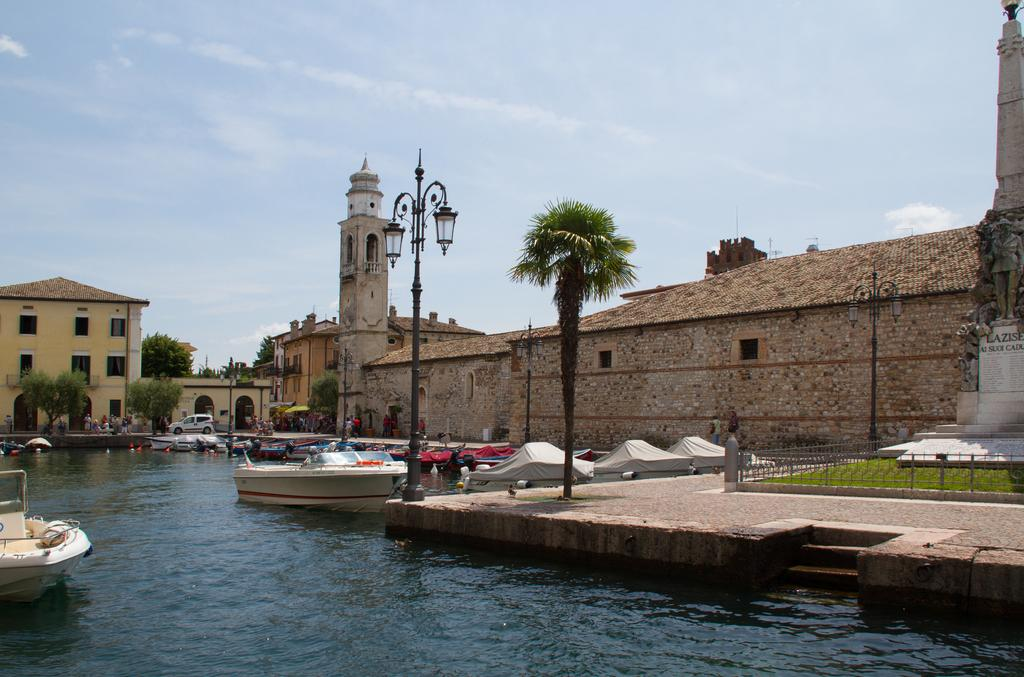What can be seen on the water in the image? There are boats on the water in the image. What type of structure can be seen in the image? There is a fence in the image. What type of artwork is present in the image? There is a statue in the image. What type of structures are visible in the image? There are buildings in the image. What type of lighting is present in the image? There are street lights in the image. What other objects can be seen in the image? There are other objects in the image, but their specific details are not mentioned in the provided facts. What can be seen in the background of the image? There are trees, vehicles, people, and the sky visible in the background of the image. What word is written on the boats in the image? There is no information about any words written on the boats in the image. What type of teeth can be seen in the image? There are no teeth present in the image. 